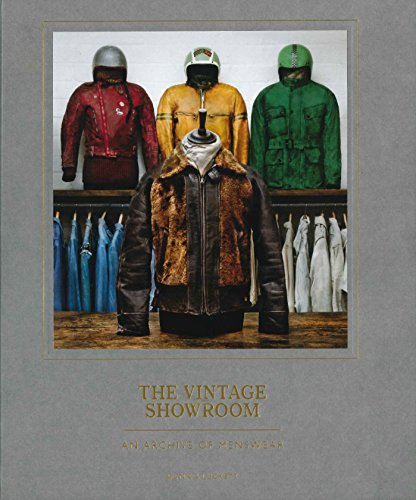Is this a fitness book? No, 'The Vintage Showroom: Vintage Menswear 2' is not a fitness book. It is a comprehensive guide to vintage menswear, detailing the historical context and evolution of men's fashion styles. 